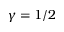Convert formula to latex. <formula><loc_0><loc_0><loc_500><loc_500>\gamma = 1 / 2</formula> 